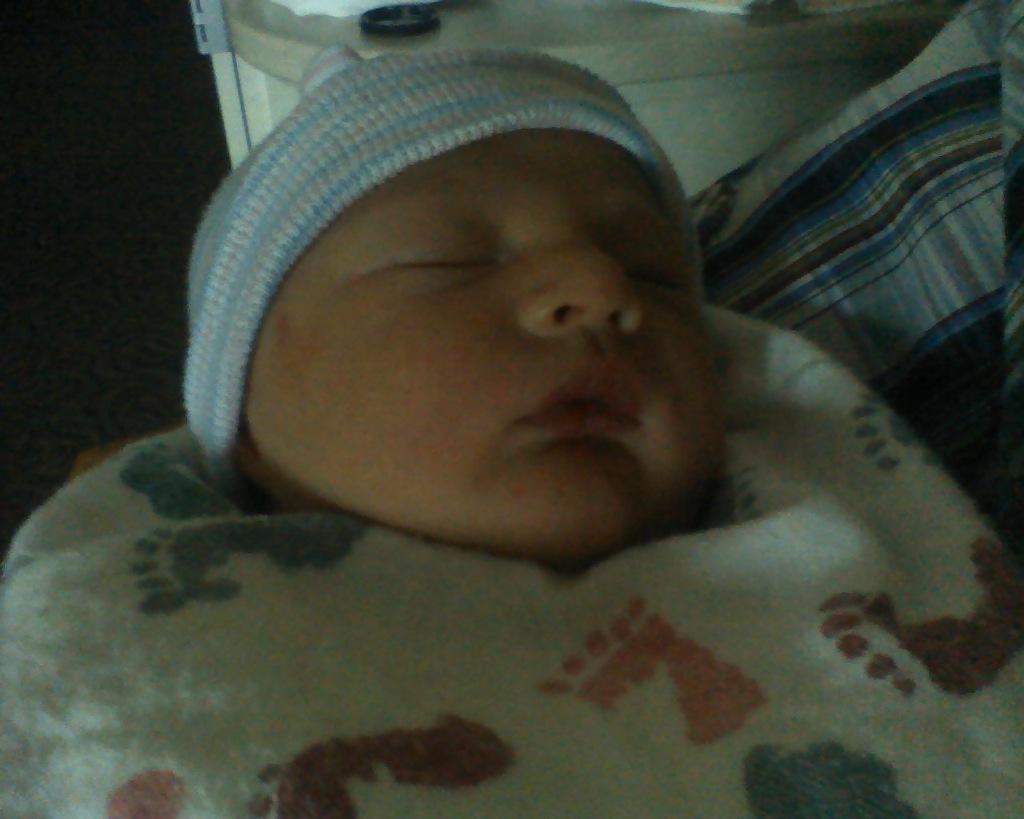Describe this image in one or two sentences. In this image we can see a child is sleeping. The background of the image is dark. 